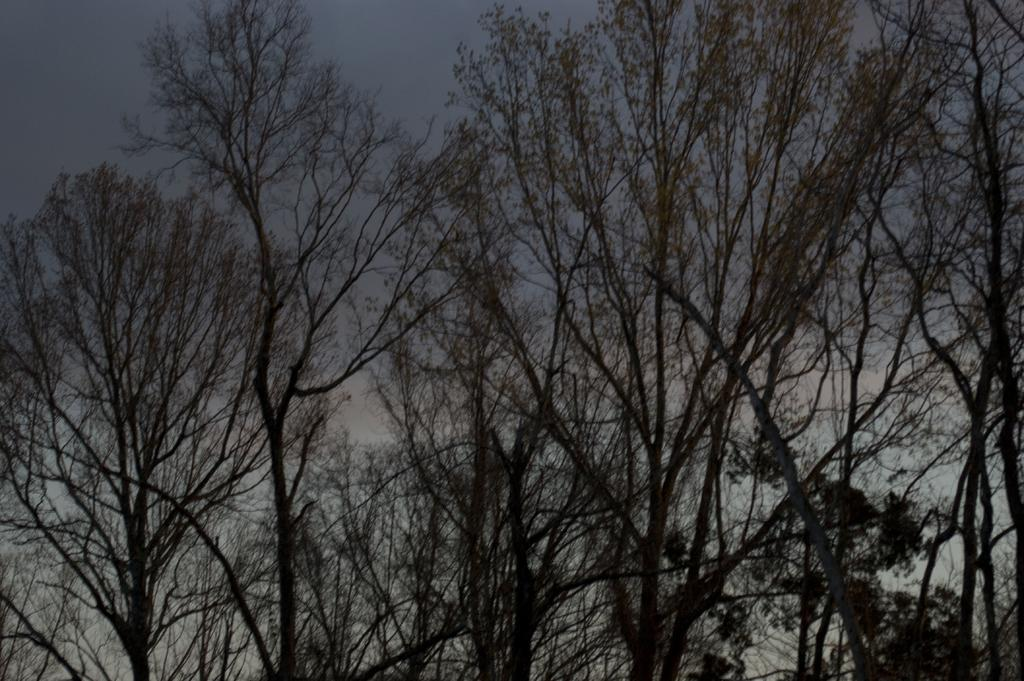What type of vegetation is present in the image? There are big trees in the image. What can be seen in the background of the image? The sky is visible in the background of the image. How many pets are sitting on the head of the person in the image? There is no person or pets present in the image; it features big trees and the sky. 